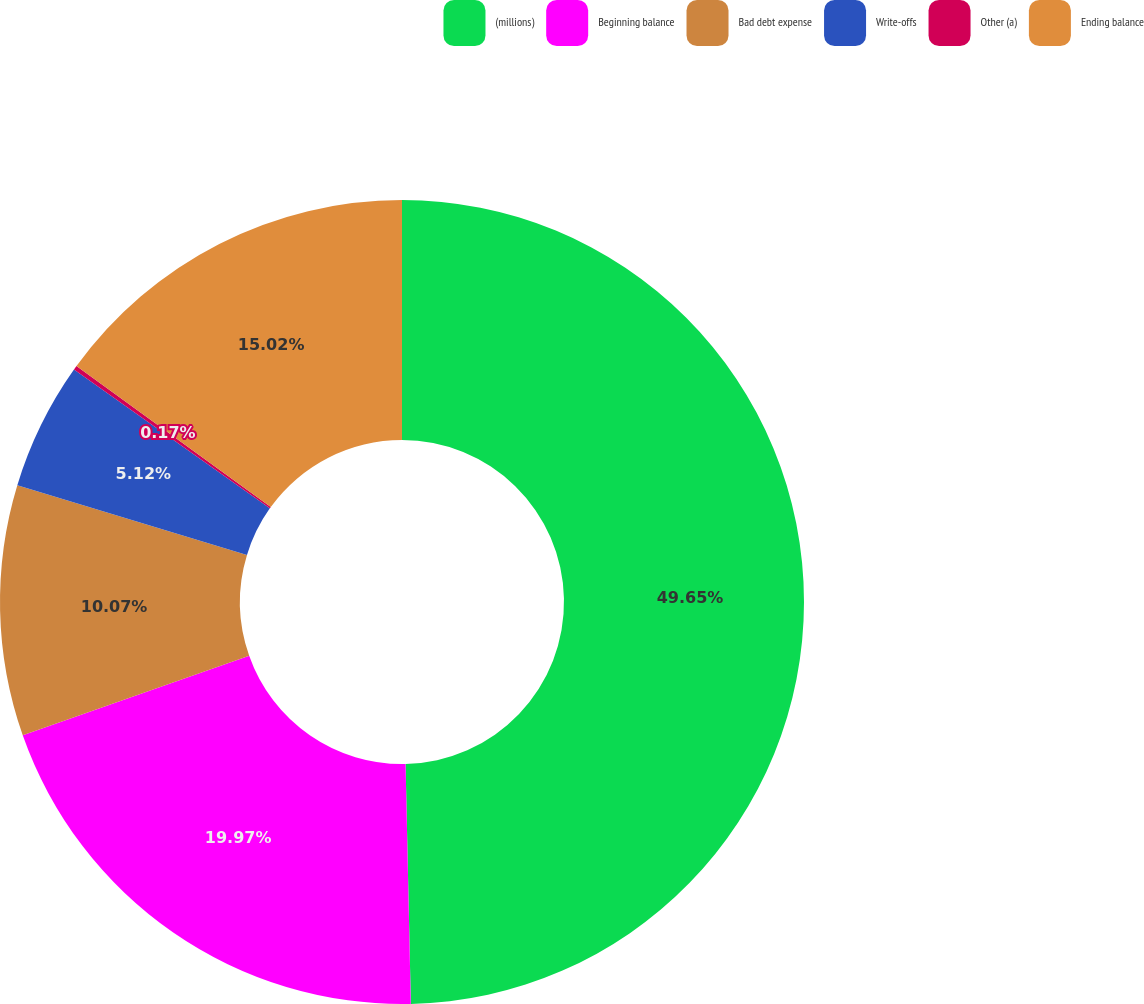Convert chart to OTSL. <chart><loc_0><loc_0><loc_500><loc_500><pie_chart><fcel>(millions)<fcel>Beginning balance<fcel>Bad debt expense<fcel>Write-offs<fcel>Other (a)<fcel>Ending balance<nl><fcel>49.65%<fcel>19.97%<fcel>10.07%<fcel>5.12%<fcel>0.17%<fcel>15.02%<nl></chart> 